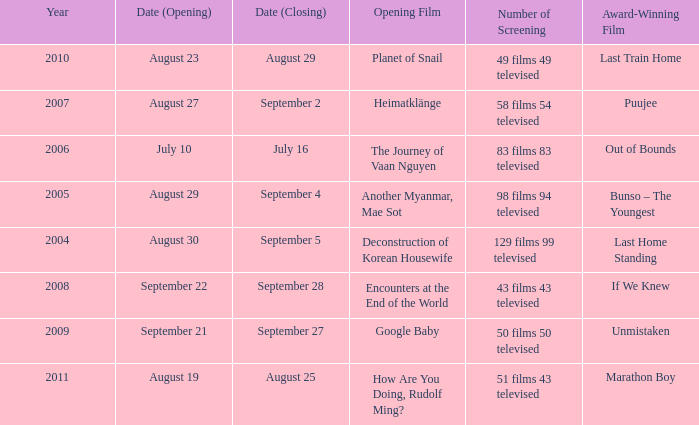How many number of screenings have an opening film of the journey of vaan nguyen? 1.0. 